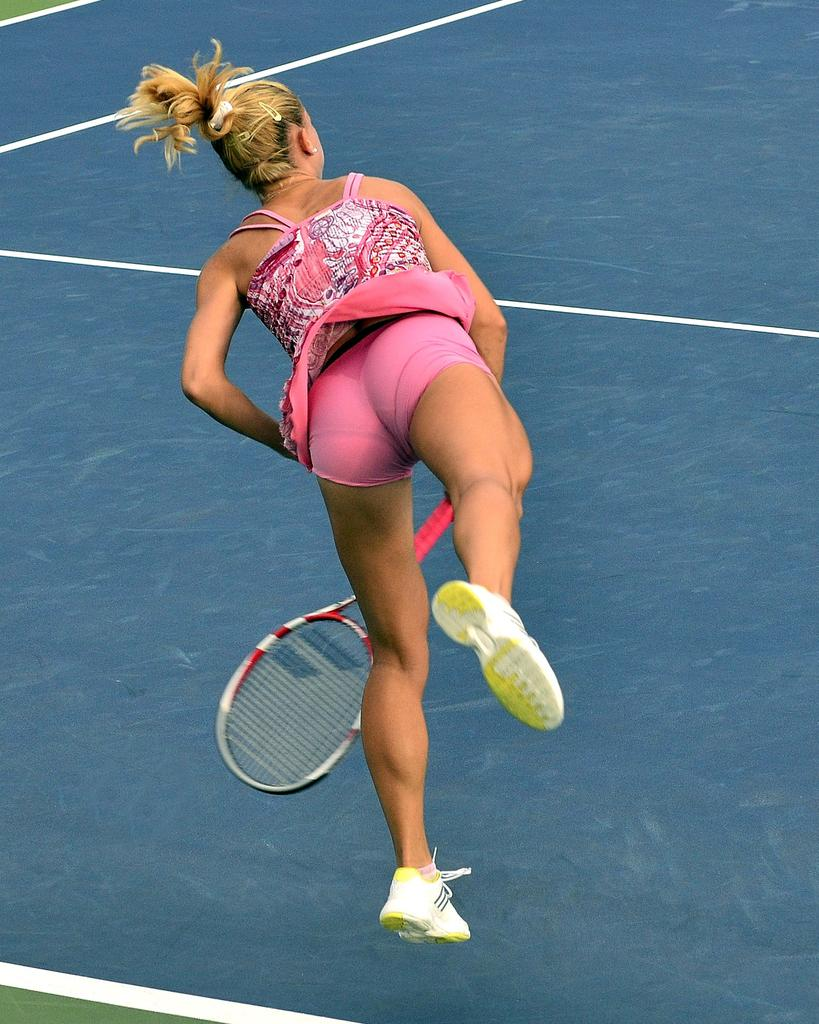What is the main structure visible in the picture? There is a stadium in the picture. What is the color of the floor mat in the stadium? The floor of the stadium has a blue color mat. What is the woman in the stadium doing? The woman is playing a game in the stadium. What object is the woman holding in her hand? The woman is holding a bat in her hand. What type of stem can be seen growing from the boundary of the stadium? There is no stem or plant visible in the image, as it is focused on the stadium and the woman playing a game. 